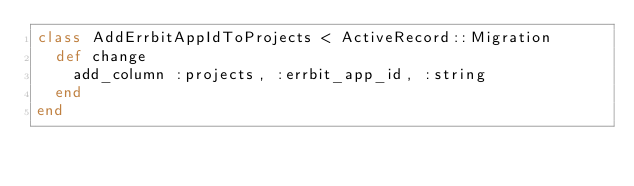Convert code to text. <code><loc_0><loc_0><loc_500><loc_500><_Ruby_>class AddErrbitAppIdToProjects < ActiveRecord::Migration
  def change
    add_column :projects, :errbit_app_id, :string
  end
end
</code> 